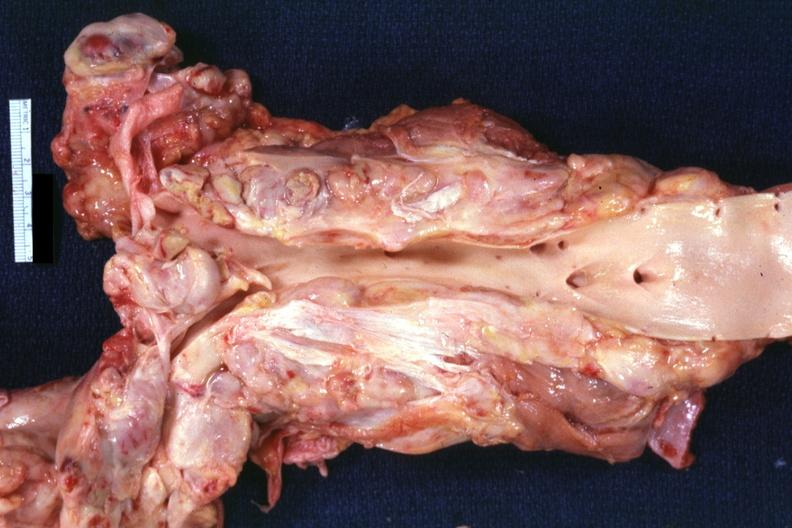what is present?
Answer the question using a single word or phrase. Lymph node 